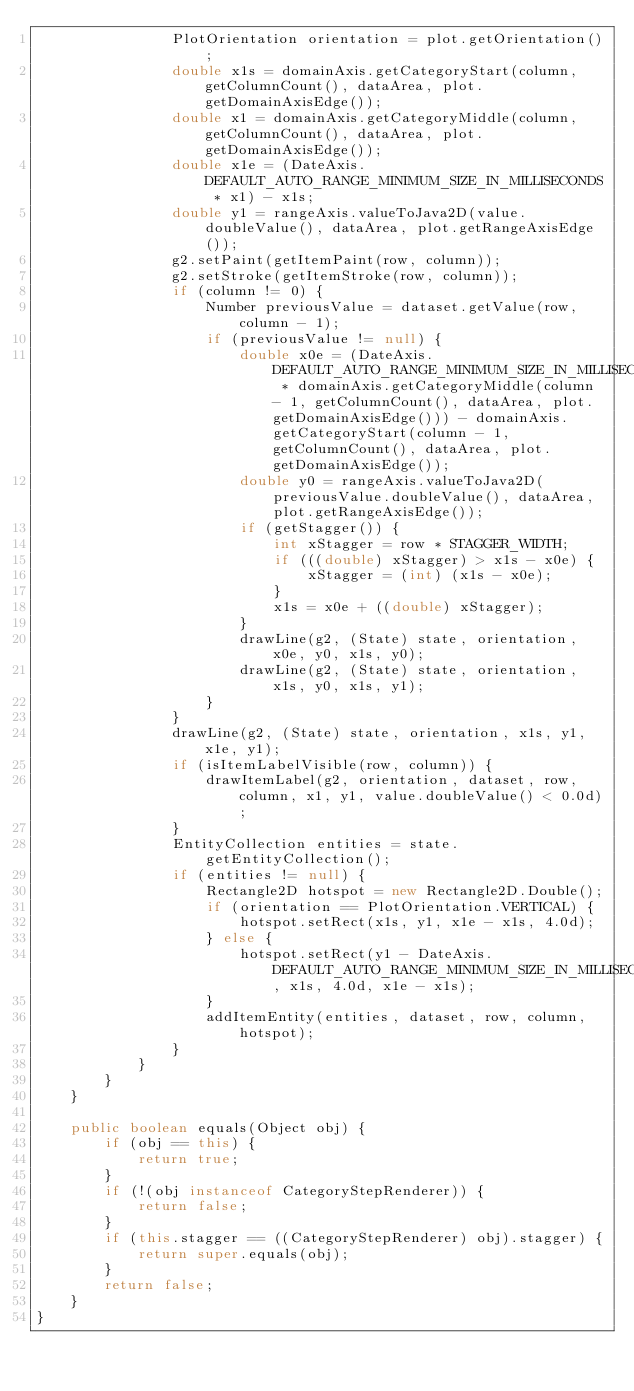Convert code to text. <code><loc_0><loc_0><loc_500><loc_500><_Java_>                PlotOrientation orientation = plot.getOrientation();
                double x1s = domainAxis.getCategoryStart(column, getColumnCount(), dataArea, plot.getDomainAxisEdge());
                double x1 = domainAxis.getCategoryMiddle(column, getColumnCount(), dataArea, plot.getDomainAxisEdge());
                double x1e = (DateAxis.DEFAULT_AUTO_RANGE_MINIMUM_SIZE_IN_MILLISECONDS * x1) - x1s;
                double y1 = rangeAxis.valueToJava2D(value.doubleValue(), dataArea, plot.getRangeAxisEdge());
                g2.setPaint(getItemPaint(row, column));
                g2.setStroke(getItemStroke(row, column));
                if (column != 0) {
                    Number previousValue = dataset.getValue(row, column - 1);
                    if (previousValue != null) {
                        double x0e = (DateAxis.DEFAULT_AUTO_RANGE_MINIMUM_SIZE_IN_MILLISECONDS * domainAxis.getCategoryMiddle(column - 1, getColumnCount(), dataArea, plot.getDomainAxisEdge())) - domainAxis.getCategoryStart(column - 1, getColumnCount(), dataArea, plot.getDomainAxisEdge());
                        double y0 = rangeAxis.valueToJava2D(previousValue.doubleValue(), dataArea, plot.getRangeAxisEdge());
                        if (getStagger()) {
                            int xStagger = row * STAGGER_WIDTH;
                            if (((double) xStagger) > x1s - x0e) {
                                xStagger = (int) (x1s - x0e);
                            }
                            x1s = x0e + ((double) xStagger);
                        }
                        drawLine(g2, (State) state, orientation, x0e, y0, x1s, y0);
                        drawLine(g2, (State) state, orientation, x1s, y0, x1s, y1);
                    }
                }
                drawLine(g2, (State) state, orientation, x1s, y1, x1e, y1);
                if (isItemLabelVisible(row, column)) {
                    drawItemLabel(g2, orientation, dataset, row, column, x1, y1, value.doubleValue() < 0.0d);
                }
                EntityCollection entities = state.getEntityCollection();
                if (entities != null) {
                    Rectangle2D hotspot = new Rectangle2D.Double();
                    if (orientation == PlotOrientation.VERTICAL) {
                        hotspot.setRect(x1s, y1, x1e - x1s, 4.0d);
                    } else {
                        hotspot.setRect(y1 - DateAxis.DEFAULT_AUTO_RANGE_MINIMUM_SIZE_IN_MILLISECONDS, x1s, 4.0d, x1e - x1s);
                    }
                    addItemEntity(entities, dataset, row, column, hotspot);
                }
            }
        }
    }

    public boolean equals(Object obj) {
        if (obj == this) {
            return true;
        }
        if (!(obj instanceof CategoryStepRenderer)) {
            return false;
        }
        if (this.stagger == ((CategoryStepRenderer) obj).stagger) {
            return super.equals(obj);
        }
        return false;
    }
}
</code> 